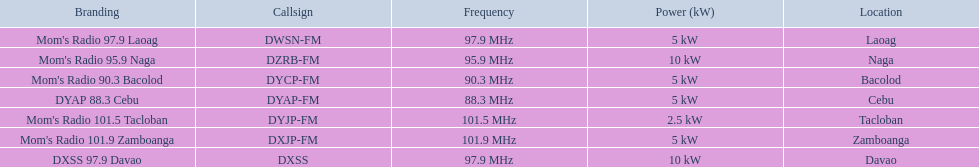Which brand identities feature a 5 kw capability? Mom's Radio 97.9 Laoag, Mom's Radio 90.3 Bacolod, DYAP 88.3 Cebu, Mom's Radio 101.9 Zamboanga. Which has a call-sign commencing with dy? Mom's Radio 90.3 Bacolod, DYAP 88.3 Cebu. Out of those, which employs the lowest frequency? DYAP 88.3 Cebu. 